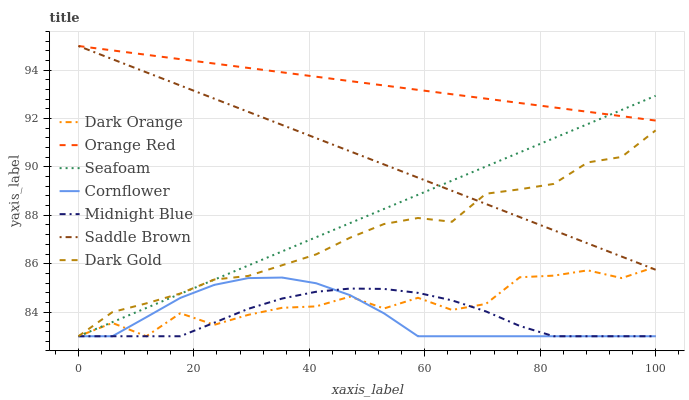Does Midnight Blue have the minimum area under the curve?
Answer yes or no. Yes. Does Orange Red have the maximum area under the curve?
Answer yes or no. Yes. Does Cornflower have the minimum area under the curve?
Answer yes or no. No. Does Cornflower have the maximum area under the curve?
Answer yes or no. No. Is Orange Red the smoothest?
Answer yes or no. Yes. Is Dark Orange the roughest?
Answer yes or no. Yes. Is Midnight Blue the smoothest?
Answer yes or no. No. Is Midnight Blue the roughest?
Answer yes or no. No. Does Dark Orange have the lowest value?
Answer yes or no. Yes. Does Orange Red have the lowest value?
Answer yes or no. No. Does Saddle Brown have the highest value?
Answer yes or no. Yes. Does Cornflower have the highest value?
Answer yes or no. No. Is Dark Orange less than Orange Red?
Answer yes or no. Yes. Is Saddle Brown greater than Midnight Blue?
Answer yes or no. Yes. Does Dark Orange intersect Dark Gold?
Answer yes or no. Yes. Is Dark Orange less than Dark Gold?
Answer yes or no. No. Is Dark Orange greater than Dark Gold?
Answer yes or no. No. Does Dark Orange intersect Orange Red?
Answer yes or no. No. 